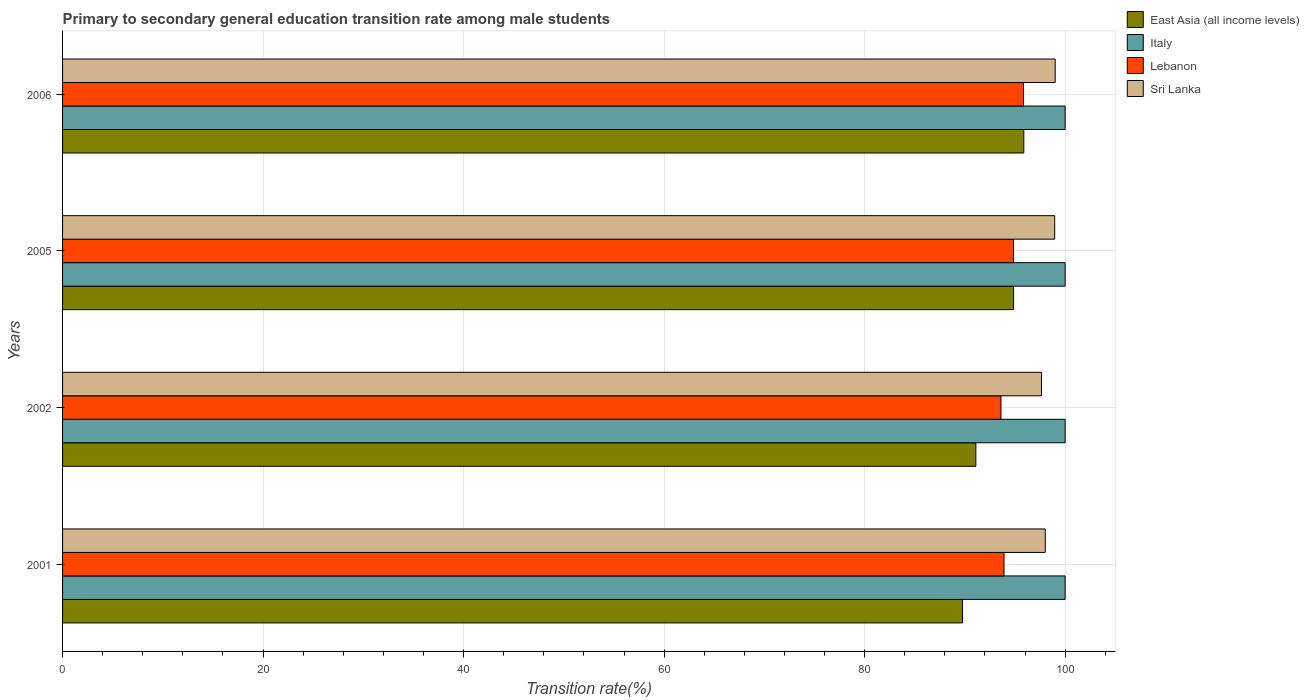How many different coloured bars are there?
Offer a terse response. 4. Are the number of bars per tick equal to the number of legend labels?
Give a very brief answer. Yes. Are the number of bars on each tick of the Y-axis equal?
Your response must be concise. Yes. How many bars are there on the 2nd tick from the top?
Give a very brief answer. 4. How many bars are there on the 1st tick from the bottom?
Your answer should be very brief. 4. In how many cases, is the number of bars for a given year not equal to the number of legend labels?
Ensure brevity in your answer.  0. What is the transition rate in Italy in 2001?
Ensure brevity in your answer.  100. Across all years, what is the minimum transition rate in Lebanon?
Keep it short and to the point. 93.6. What is the total transition rate in Sri Lanka in the graph?
Your answer should be very brief. 393.63. What is the difference between the transition rate in Lebanon in 2001 and that in 2005?
Your answer should be compact. -0.94. What is the difference between the transition rate in East Asia (all income levels) in 2006 and the transition rate in Italy in 2005?
Provide a short and direct response. -4.12. In the year 2002, what is the difference between the transition rate in Lebanon and transition rate in Sri Lanka?
Your response must be concise. -4.04. What is the ratio of the transition rate in Sri Lanka in 2002 to that in 2006?
Your response must be concise. 0.99. What is the difference between the highest and the second highest transition rate in East Asia (all income levels)?
Offer a very short reply. 1.02. What is the difference between the highest and the lowest transition rate in Sri Lanka?
Provide a succinct answer. 1.37. What does the 4th bar from the top in 2006 represents?
Offer a very short reply. East Asia (all income levels). What does the 3rd bar from the bottom in 2001 represents?
Make the answer very short. Lebanon. How many years are there in the graph?
Your answer should be compact. 4. Are the values on the major ticks of X-axis written in scientific E-notation?
Offer a terse response. No. Does the graph contain any zero values?
Make the answer very short. No. Does the graph contain grids?
Provide a succinct answer. Yes. Where does the legend appear in the graph?
Your answer should be very brief. Top right. What is the title of the graph?
Provide a succinct answer. Primary to secondary general education transition rate among male students. Does "Sint Maarten (Dutch part)" appear as one of the legend labels in the graph?
Provide a short and direct response. No. What is the label or title of the X-axis?
Provide a short and direct response. Transition rate(%). What is the label or title of the Y-axis?
Offer a terse response. Years. What is the Transition rate(%) in East Asia (all income levels) in 2001?
Give a very brief answer. 89.76. What is the Transition rate(%) of Lebanon in 2001?
Your response must be concise. 93.9. What is the Transition rate(%) of Sri Lanka in 2001?
Give a very brief answer. 98.02. What is the Transition rate(%) in East Asia (all income levels) in 2002?
Provide a short and direct response. 91.1. What is the Transition rate(%) of Italy in 2002?
Your answer should be compact. 100. What is the Transition rate(%) in Lebanon in 2002?
Your answer should be very brief. 93.6. What is the Transition rate(%) in Sri Lanka in 2002?
Your answer should be compact. 97.64. What is the Transition rate(%) of East Asia (all income levels) in 2005?
Offer a terse response. 94.86. What is the Transition rate(%) in Italy in 2005?
Offer a very short reply. 100. What is the Transition rate(%) of Lebanon in 2005?
Your answer should be compact. 94.85. What is the Transition rate(%) of Sri Lanka in 2005?
Make the answer very short. 98.96. What is the Transition rate(%) in East Asia (all income levels) in 2006?
Your answer should be very brief. 95.88. What is the Transition rate(%) of Lebanon in 2006?
Your answer should be compact. 95.85. What is the Transition rate(%) in Sri Lanka in 2006?
Provide a succinct answer. 99.01. Across all years, what is the maximum Transition rate(%) of East Asia (all income levels)?
Ensure brevity in your answer.  95.88. Across all years, what is the maximum Transition rate(%) of Lebanon?
Your response must be concise. 95.85. Across all years, what is the maximum Transition rate(%) in Sri Lanka?
Offer a very short reply. 99.01. Across all years, what is the minimum Transition rate(%) of East Asia (all income levels)?
Give a very brief answer. 89.76. Across all years, what is the minimum Transition rate(%) of Lebanon?
Keep it short and to the point. 93.6. Across all years, what is the minimum Transition rate(%) of Sri Lanka?
Offer a terse response. 97.64. What is the total Transition rate(%) of East Asia (all income levels) in the graph?
Offer a very short reply. 371.6. What is the total Transition rate(%) in Lebanon in the graph?
Provide a succinct answer. 378.2. What is the total Transition rate(%) of Sri Lanka in the graph?
Your answer should be compact. 393.63. What is the difference between the Transition rate(%) in East Asia (all income levels) in 2001 and that in 2002?
Your answer should be compact. -1.33. What is the difference between the Transition rate(%) of Italy in 2001 and that in 2002?
Offer a terse response. 0. What is the difference between the Transition rate(%) in Lebanon in 2001 and that in 2002?
Offer a very short reply. 0.3. What is the difference between the Transition rate(%) in Sri Lanka in 2001 and that in 2002?
Offer a terse response. 0.38. What is the difference between the Transition rate(%) in East Asia (all income levels) in 2001 and that in 2005?
Ensure brevity in your answer.  -5.1. What is the difference between the Transition rate(%) in Lebanon in 2001 and that in 2005?
Your answer should be very brief. -0.94. What is the difference between the Transition rate(%) of Sri Lanka in 2001 and that in 2005?
Keep it short and to the point. -0.94. What is the difference between the Transition rate(%) in East Asia (all income levels) in 2001 and that in 2006?
Your answer should be very brief. -6.11. What is the difference between the Transition rate(%) of Lebanon in 2001 and that in 2006?
Keep it short and to the point. -1.95. What is the difference between the Transition rate(%) in Sri Lanka in 2001 and that in 2006?
Ensure brevity in your answer.  -0.99. What is the difference between the Transition rate(%) in East Asia (all income levels) in 2002 and that in 2005?
Offer a very short reply. -3.76. What is the difference between the Transition rate(%) in Lebanon in 2002 and that in 2005?
Your response must be concise. -1.25. What is the difference between the Transition rate(%) of Sri Lanka in 2002 and that in 2005?
Ensure brevity in your answer.  -1.32. What is the difference between the Transition rate(%) of East Asia (all income levels) in 2002 and that in 2006?
Give a very brief answer. -4.78. What is the difference between the Transition rate(%) in Lebanon in 2002 and that in 2006?
Keep it short and to the point. -2.25. What is the difference between the Transition rate(%) in Sri Lanka in 2002 and that in 2006?
Provide a succinct answer. -1.37. What is the difference between the Transition rate(%) of East Asia (all income levels) in 2005 and that in 2006?
Keep it short and to the point. -1.02. What is the difference between the Transition rate(%) of Lebanon in 2005 and that in 2006?
Your answer should be compact. -1. What is the difference between the Transition rate(%) in Sri Lanka in 2005 and that in 2006?
Give a very brief answer. -0.05. What is the difference between the Transition rate(%) of East Asia (all income levels) in 2001 and the Transition rate(%) of Italy in 2002?
Keep it short and to the point. -10.24. What is the difference between the Transition rate(%) in East Asia (all income levels) in 2001 and the Transition rate(%) in Lebanon in 2002?
Ensure brevity in your answer.  -3.84. What is the difference between the Transition rate(%) of East Asia (all income levels) in 2001 and the Transition rate(%) of Sri Lanka in 2002?
Provide a succinct answer. -7.88. What is the difference between the Transition rate(%) of Italy in 2001 and the Transition rate(%) of Lebanon in 2002?
Your response must be concise. 6.4. What is the difference between the Transition rate(%) of Italy in 2001 and the Transition rate(%) of Sri Lanka in 2002?
Your answer should be very brief. 2.36. What is the difference between the Transition rate(%) of Lebanon in 2001 and the Transition rate(%) of Sri Lanka in 2002?
Give a very brief answer. -3.74. What is the difference between the Transition rate(%) in East Asia (all income levels) in 2001 and the Transition rate(%) in Italy in 2005?
Provide a short and direct response. -10.24. What is the difference between the Transition rate(%) in East Asia (all income levels) in 2001 and the Transition rate(%) in Lebanon in 2005?
Give a very brief answer. -5.09. What is the difference between the Transition rate(%) of East Asia (all income levels) in 2001 and the Transition rate(%) of Sri Lanka in 2005?
Offer a very short reply. -9.19. What is the difference between the Transition rate(%) of Italy in 2001 and the Transition rate(%) of Lebanon in 2005?
Give a very brief answer. 5.15. What is the difference between the Transition rate(%) in Italy in 2001 and the Transition rate(%) in Sri Lanka in 2005?
Your answer should be compact. 1.04. What is the difference between the Transition rate(%) of Lebanon in 2001 and the Transition rate(%) of Sri Lanka in 2005?
Your response must be concise. -5.05. What is the difference between the Transition rate(%) of East Asia (all income levels) in 2001 and the Transition rate(%) of Italy in 2006?
Offer a very short reply. -10.24. What is the difference between the Transition rate(%) in East Asia (all income levels) in 2001 and the Transition rate(%) in Lebanon in 2006?
Offer a terse response. -6.09. What is the difference between the Transition rate(%) in East Asia (all income levels) in 2001 and the Transition rate(%) in Sri Lanka in 2006?
Your answer should be very brief. -9.24. What is the difference between the Transition rate(%) in Italy in 2001 and the Transition rate(%) in Lebanon in 2006?
Keep it short and to the point. 4.15. What is the difference between the Transition rate(%) in Lebanon in 2001 and the Transition rate(%) in Sri Lanka in 2006?
Your answer should be compact. -5.1. What is the difference between the Transition rate(%) of East Asia (all income levels) in 2002 and the Transition rate(%) of Italy in 2005?
Offer a terse response. -8.9. What is the difference between the Transition rate(%) of East Asia (all income levels) in 2002 and the Transition rate(%) of Lebanon in 2005?
Ensure brevity in your answer.  -3.75. What is the difference between the Transition rate(%) in East Asia (all income levels) in 2002 and the Transition rate(%) in Sri Lanka in 2005?
Keep it short and to the point. -7.86. What is the difference between the Transition rate(%) of Italy in 2002 and the Transition rate(%) of Lebanon in 2005?
Your response must be concise. 5.15. What is the difference between the Transition rate(%) of Italy in 2002 and the Transition rate(%) of Sri Lanka in 2005?
Provide a short and direct response. 1.04. What is the difference between the Transition rate(%) of Lebanon in 2002 and the Transition rate(%) of Sri Lanka in 2005?
Provide a short and direct response. -5.36. What is the difference between the Transition rate(%) of East Asia (all income levels) in 2002 and the Transition rate(%) of Italy in 2006?
Make the answer very short. -8.9. What is the difference between the Transition rate(%) in East Asia (all income levels) in 2002 and the Transition rate(%) in Lebanon in 2006?
Your answer should be compact. -4.75. What is the difference between the Transition rate(%) of East Asia (all income levels) in 2002 and the Transition rate(%) of Sri Lanka in 2006?
Provide a short and direct response. -7.91. What is the difference between the Transition rate(%) in Italy in 2002 and the Transition rate(%) in Lebanon in 2006?
Offer a very short reply. 4.15. What is the difference between the Transition rate(%) of Italy in 2002 and the Transition rate(%) of Sri Lanka in 2006?
Your answer should be very brief. 0.99. What is the difference between the Transition rate(%) in Lebanon in 2002 and the Transition rate(%) in Sri Lanka in 2006?
Offer a very short reply. -5.41. What is the difference between the Transition rate(%) of East Asia (all income levels) in 2005 and the Transition rate(%) of Italy in 2006?
Offer a terse response. -5.14. What is the difference between the Transition rate(%) of East Asia (all income levels) in 2005 and the Transition rate(%) of Lebanon in 2006?
Your answer should be compact. -0.99. What is the difference between the Transition rate(%) in East Asia (all income levels) in 2005 and the Transition rate(%) in Sri Lanka in 2006?
Ensure brevity in your answer.  -4.15. What is the difference between the Transition rate(%) of Italy in 2005 and the Transition rate(%) of Lebanon in 2006?
Offer a very short reply. 4.15. What is the difference between the Transition rate(%) in Lebanon in 2005 and the Transition rate(%) in Sri Lanka in 2006?
Keep it short and to the point. -4.16. What is the average Transition rate(%) of East Asia (all income levels) per year?
Make the answer very short. 92.9. What is the average Transition rate(%) in Italy per year?
Keep it short and to the point. 100. What is the average Transition rate(%) of Lebanon per year?
Provide a short and direct response. 94.55. What is the average Transition rate(%) of Sri Lanka per year?
Ensure brevity in your answer.  98.41. In the year 2001, what is the difference between the Transition rate(%) in East Asia (all income levels) and Transition rate(%) in Italy?
Ensure brevity in your answer.  -10.24. In the year 2001, what is the difference between the Transition rate(%) in East Asia (all income levels) and Transition rate(%) in Lebanon?
Give a very brief answer. -4.14. In the year 2001, what is the difference between the Transition rate(%) in East Asia (all income levels) and Transition rate(%) in Sri Lanka?
Your answer should be very brief. -8.26. In the year 2001, what is the difference between the Transition rate(%) in Italy and Transition rate(%) in Lebanon?
Your answer should be very brief. 6.1. In the year 2001, what is the difference between the Transition rate(%) of Italy and Transition rate(%) of Sri Lanka?
Offer a very short reply. 1.98. In the year 2001, what is the difference between the Transition rate(%) of Lebanon and Transition rate(%) of Sri Lanka?
Your answer should be very brief. -4.12. In the year 2002, what is the difference between the Transition rate(%) of East Asia (all income levels) and Transition rate(%) of Italy?
Your answer should be very brief. -8.9. In the year 2002, what is the difference between the Transition rate(%) of East Asia (all income levels) and Transition rate(%) of Lebanon?
Provide a succinct answer. -2.5. In the year 2002, what is the difference between the Transition rate(%) of East Asia (all income levels) and Transition rate(%) of Sri Lanka?
Your response must be concise. -6.54. In the year 2002, what is the difference between the Transition rate(%) of Italy and Transition rate(%) of Lebanon?
Your answer should be very brief. 6.4. In the year 2002, what is the difference between the Transition rate(%) of Italy and Transition rate(%) of Sri Lanka?
Your response must be concise. 2.36. In the year 2002, what is the difference between the Transition rate(%) in Lebanon and Transition rate(%) in Sri Lanka?
Keep it short and to the point. -4.04. In the year 2005, what is the difference between the Transition rate(%) of East Asia (all income levels) and Transition rate(%) of Italy?
Give a very brief answer. -5.14. In the year 2005, what is the difference between the Transition rate(%) of East Asia (all income levels) and Transition rate(%) of Lebanon?
Provide a short and direct response. 0.01. In the year 2005, what is the difference between the Transition rate(%) in East Asia (all income levels) and Transition rate(%) in Sri Lanka?
Offer a very short reply. -4.1. In the year 2005, what is the difference between the Transition rate(%) in Italy and Transition rate(%) in Lebanon?
Ensure brevity in your answer.  5.15. In the year 2005, what is the difference between the Transition rate(%) of Italy and Transition rate(%) of Sri Lanka?
Ensure brevity in your answer.  1.04. In the year 2005, what is the difference between the Transition rate(%) of Lebanon and Transition rate(%) of Sri Lanka?
Provide a succinct answer. -4.11. In the year 2006, what is the difference between the Transition rate(%) in East Asia (all income levels) and Transition rate(%) in Italy?
Ensure brevity in your answer.  -4.12. In the year 2006, what is the difference between the Transition rate(%) of East Asia (all income levels) and Transition rate(%) of Lebanon?
Give a very brief answer. 0.03. In the year 2006, what is the difference between the Transition rate(%) in East Asia (all income levels) and Transition rate(%) in Sri Lanka?
Offer a very short reply. -3.13. In the year 2006, what is the difference between the Transition rate(%) of Italy and Transition rate(%) of Lebanon?
Your answer should be compact. 4.15. In the year 2006, what is the difference between the Transition rate(%) in Lebanon and Transition rate(%) in Sri Lanka?
Provide a succinct answer. -3.16. What is the ratio of the Transition rate(%) of East Asia (all income levels) in 2001 to that in 2002?
Provide a succinct answer. 0.99. What is the ratio of the Transition rate(%) in East Asia (all income levels) in 2001 to that in 2005?
Your answer should be very brief. 0.95. What is the ratio of the Transition rate(%) in Italy in 2001 to that in 2005?
Keep it short and to the point. 1. What is the ratio of the Transition rate(%) in East Asia (all income levels) in 2001 to that in 2006?
Make the answer very short. 0.94. What is the ratio of the Transition rate(%) in Italy in 2001 to that in 2006?
Ensure brevity in your answer.  1. What is the ratio of the Transition rate(%) in Lebanon in 2001 to that in 2006?
Your answer should be very brief. 0.98. What is the ratio of the Transition rate(%) of Sri Lanka in 2001 to that in 2006?
Ensure brevity in your answer.  0.99. What is the ratio of the Transition rate(%) of East Asia (all income levels) in 2002 to that in 2005?
Offer a very short reply. 0.96. What is the ratio of the Transition rate(%) of Italy in 2002 to that in 2005?
Ensure brevity in your answer.  1. What is the ratio of the Transition rate(%) in Lebanon in 2002 to that in 2005?
Ensure brevity in your answer.  0.99. What is the ratio of the Transition rate(%) in Sri Lanka in 2002 to that in 2005?
Your answer should be compact. 0.99. What is the ratio of the Transition rate(%) of East Asia (all income levels) in 2002 to that in 2006?
Ensure brevity in your answer.  0.95. What is the ratio of the Transition rate(%) in Italy in 2002 to that in 2006?
Your response must be concise. 1. What is the ratio of the Transition rate(%) in Lebanon in 2002 to that in 2006?
Give a very brief answer. 0.98. What is the ratio of the Transition rate(%) in Sri Lanka in 2002 to that in 2006?
Give a very brief answer. 0.99. What is the ratio of the Transition rate(%) in Lebanon in 2005 to that in 2006?
Provide a short and direct response. 0.99. What is the ratio of the Transition rate(%) in Sri Lanka in 2005 to that in 2006?
Offer a very short reply. 1. What is the difference between the highest and the second highest Transition rate(%) of East Asia (all income levels)?
Provide a succinct answer. 1.02. What is the difference between the highest and the second highest Transition rate(%) in Italy?
Ensure brevity in your answer.  0. What is the difference between the highest and the second highest Transition rate(%) of Sri Lanka?
Provide a short and direct response. 0.05. What is the difference between the highest and the lowest Transition rate(%) of East Asia (all income levels)?
Provide a short and direct response. 6.11. What is the difference between the highest and the lowest Transition rate(%) in Italy?
Make the answer very short. 0. What is the difference between the highest and the lowest Transition rate(%) of Lebanon?
Ensure brevity in your answer.  2.25. What is the difference between the highest and the lowest Transition rate(%) in Sri Lanka?
Keep it short and to the point. 1.37. 